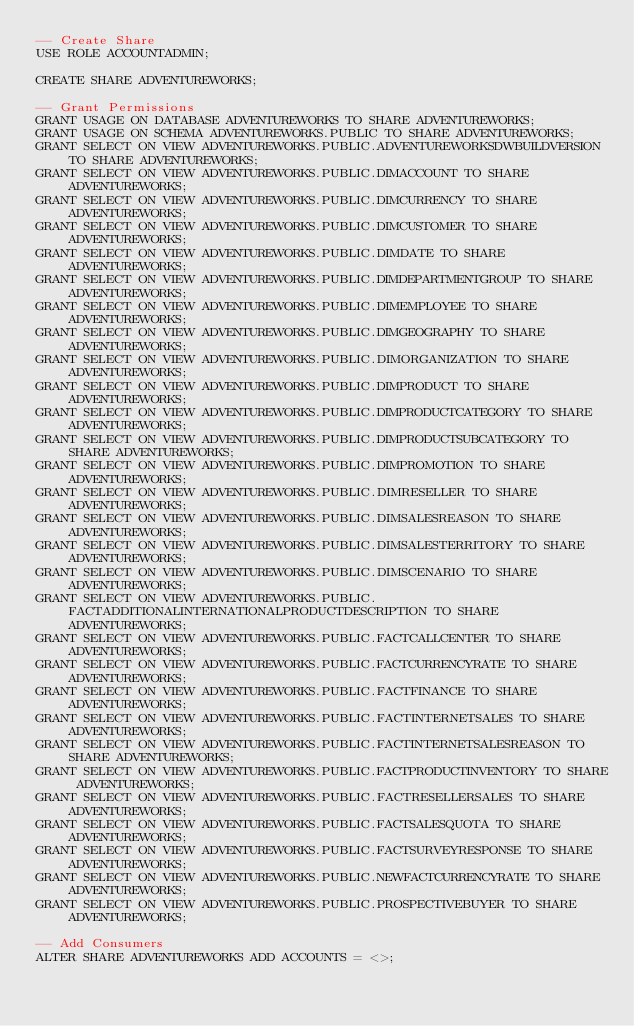<code> <loc_0><loc_0><loc_500><loc_500><_SQL_>-- Create Share
USE ROLE ACCOUNTADMIN;

CREATE SHARE ADVENTUREWORKS;

-- Grant Permissions
GRANT USAGE ON DATABASE ADVENTUREWORKS TO SHARE ADVENTUREWORKS;
GRANT USAGE ON SCHEMA ADVENTUREWORKS.PUBLIC TO SHARE ADVENTUREWORKS;
GRANT SELECT ON VIEW ADVENTUREWORKS.PUBLIC.ADVENTUREWORKSDWBUILDVERSION TO SHARE ADVENTUREWORKS;
GRANT SELECT ON VIEW ADVENTUREWORKS.PUBLIC.DIMACCOUNT TO SHARE ADVENTUREWORKS;
GRANT SELECT ON VIEW ADVENTUREWORKS.PUBLIC.DIMCURRENCY TO SHARE ADVENTUREWORKS;
GRANT SELECT ON VIEW ADVENTUREWORKS.PUBLIC.DIMCUSTOMER TO SHARE ADVENTUREWORKS;
GRANT SELECT ON VIEW ADVENTUREWORKS.PUBLIC.DIMDATE TO SHARE ADVENTUREWORKS;
GRANT SELECT ON VIEW ADVENTUREWORKS.PUBLIC.DIMDEPARTMENTGROUP TO SHARE ADVENTUREWORKS;
GRANT SELECT ON VIEW ADVENTUREWORKS.PUBLIC.DIMEMPLOYEE TO SHARE ADVENTUREWORKS;
GRANT SELECT ON VIEW ADVENTUREWORKS.PUBLIC.DIMGEOGRAPHY TO SHARE ADVENTUREWORKS;
GRANT SELECT ON VIEW ADVENTUREWORKS.PUBLIC.DIMORGANIZATION TO SHARE ADVENTUREWORKS;
GRANT SELECT ON VIEW ADVENTUREWORKS.PUBLIC.DIMPRODUCT TO SHARE ADVENTUREWORKS;
GRANT SELECT ON VIEW ADVENTUREWORKS.PUBLIC.DIMPRODUCTCATEGORY TO SHARE ADVENTUREWORKS;
GRANT SELECT ON VIEW ADVENTUREWORKS.PUBLIC.DIMPRODUCTSUBCATEGORY TO SHARE ADVENTUREWORKS;
GRANT SELECT ON VIEW ADVENTUREWORKS.PUBLIC.DIMPROMOTION TO SHARE ADVENTUREWORKS;
GRANT SELECT ON VIEW ADVENTUREWORKS.PUBLIC.DIMRESELLER TO SHARE ADVENTUREWORKS;
GRANT SELECT ON VIEW ADVENTUREWORKS.PUBLIC.DIMSALESREASON TO SHARE ADVENTUREWORKS;
GRANT SELECT ON VIEW ADVENTUREWORKS.PUBLIC.DIMSALESTERRITORY TO SHARE ADVENTUREWORKS;
GRANT SELECT ON VIEW ADVENTUREWORKS.PUBLIC.DIMSCENARIO TO SHARE ADVENTUREWORKS;
GRANT SELECT ON VIEW ADVENTUREWORKS.PUBLIC.FACTADDITIONALINTERNATIONALPRODUCTDESCRIPTION TO SHARE ADVENTUREWORKS;
GRANT SELECT ON VIEW ADVENTUREWORKS.PUBLIC.FACTCALLCENTER TO SHARE ADVENTUREWORKS;
GRANT SELECT ON VIEW ADVENTUREWORKS.PUBLIC.FACTCURRENCYRATE TO SHARE ADVENTUREWORKS;
GRANT SELECT ON VIEW ADVENTUREWORKS.PUBLIC.FACTFINANCE TO SHARE ADVENTUREWORKS;
GRANT SELECT ON VIEW ADVENTUREWORKS.PUBLIC.FACTINTERNETSALES TO SHARE ADVENTUREWORKS;
GRANT SELECT ON VIEW ADVENTUREWORKS.PUBLIC.FACTINTERNETSALESREASON TO SHARE ADVENTUREWORKS;
GRANT SELECT ON VIEW ADVENTUREWORKS.PUBLIC.FACTPRODUCTINVENTORY TO SHARE ADVENTUREWORKS;
GRANT SELECT ON VIEW ADVENTUREWORKS.PUBLIC.FACTRESELLERSALES TO SHARE ADVENTUREWORKS;
GRANT SELECT ON VIEW ADVENTUREWORKS.PUBLIC.FACTSALESQUOTA TO SHARE ADVENTUREWORKS;
GRANT SELECT ON VIEW ADVENTUREWORKS.PUBLIC.FACTSURVEYRESPONSE TO SHARE ADVENTUREWORKS;
GRANT SELECT ON VIEW ADVENTUREWORKS.PUBLIC.NEWFACTCURRENCYRATE TO SHARE ADVENTUREWORKS;
GRANT SELECT ON VIEW ADVENTUREWORKS.PUBLIC.PROSPECTIVEBUYER TO SHARE ADVENTUREWORKS;

-- Add Consumers
ALTER SHARE ADVENTUREWORKS ADD ACCOUNTS = <>;
</code> 